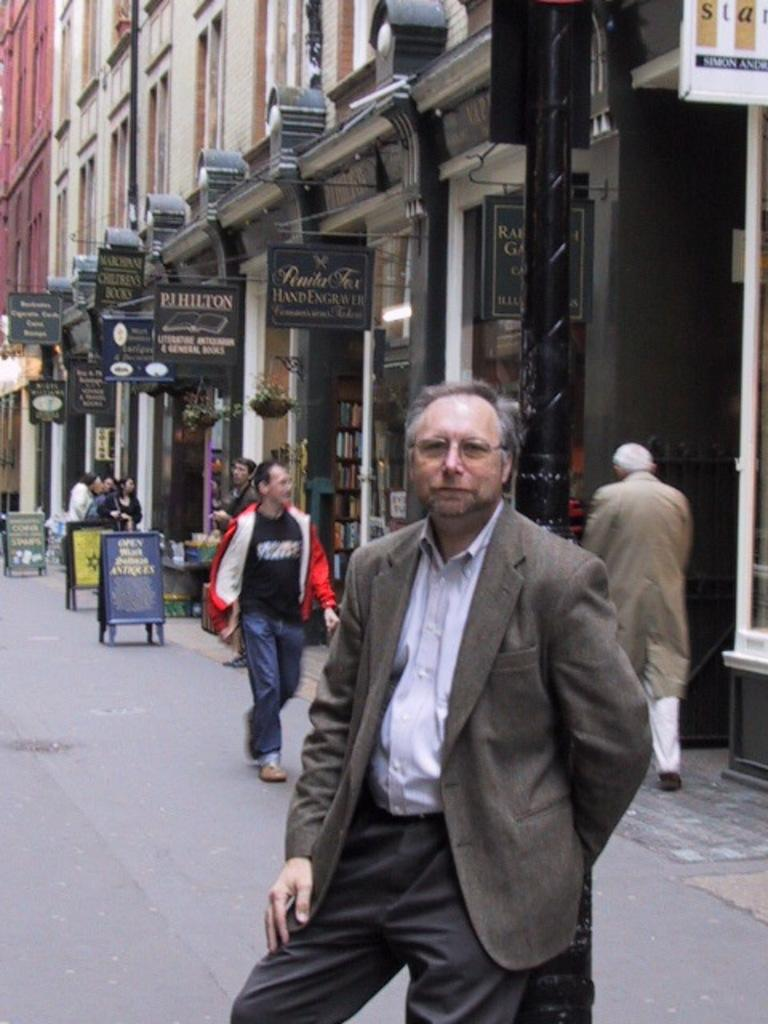What is the main feature of the image? There is a road in the image. What are the people on the road doing? There are people standing on the road. What else can be seen in the image besides the road and people? There are boards and buildings visible in the image. Can you see a fight happening between the people on the road in the image? There is no fight happening between the people on the road in the image. What type of leather is visible on the buildings in the image? There is no leather visible on the buildings in the image. 